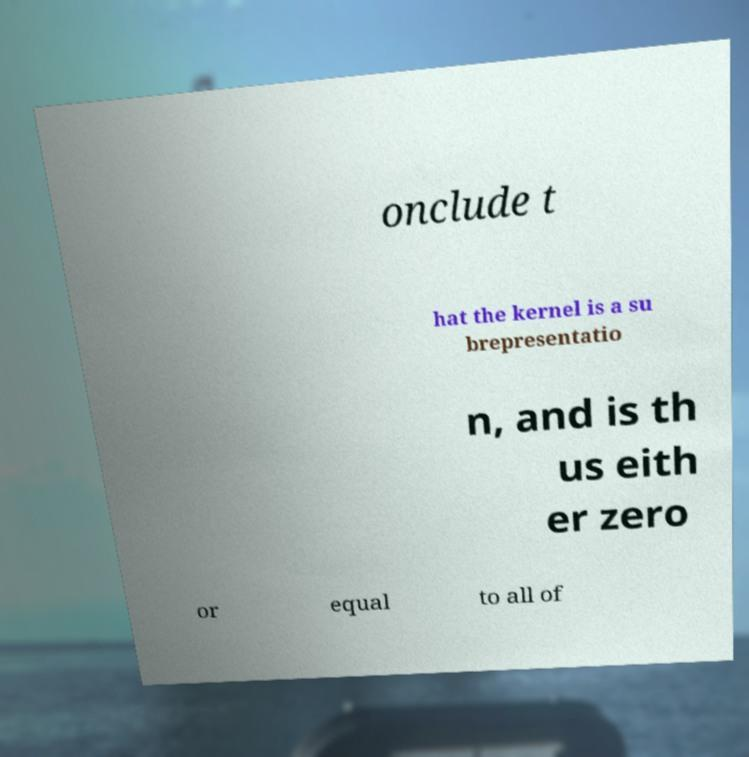Can you read and provide the text displayed in the image?This photo seems to have some interesting text. Can you extract and type it out for me? onclude t hat the kernel is a su brepresentatio n, and is th us eith er zero or equal to all of 